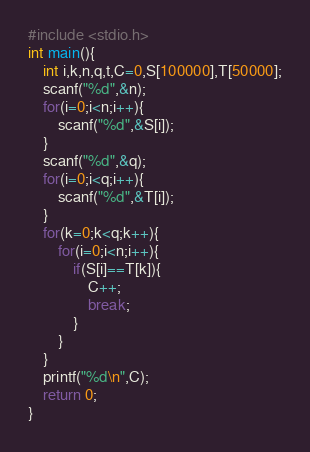<code> <loc_0><loc_0><loc_500><loc_500><_C_>#include <stdio.h>
int main(){
	int i,k,n,q,t,C=0,S[100000],T[50000];
	scanf("%d",&n);
	for(i=0;i<n;i++){
		scanf("%d",&S[i]);
	}
	scanf("%d",&q);
	for(i=0;i<q;i++){
		scanf("%d",&T[i]);
	}
	for(k=0;k<q;k++){
		for(i=0;i<n;i++){
			if(S[i]==T[k]){
				C++;
				break;
			}
		}
	}
	printf("%d\n",C);
	return 0;
}</code> 